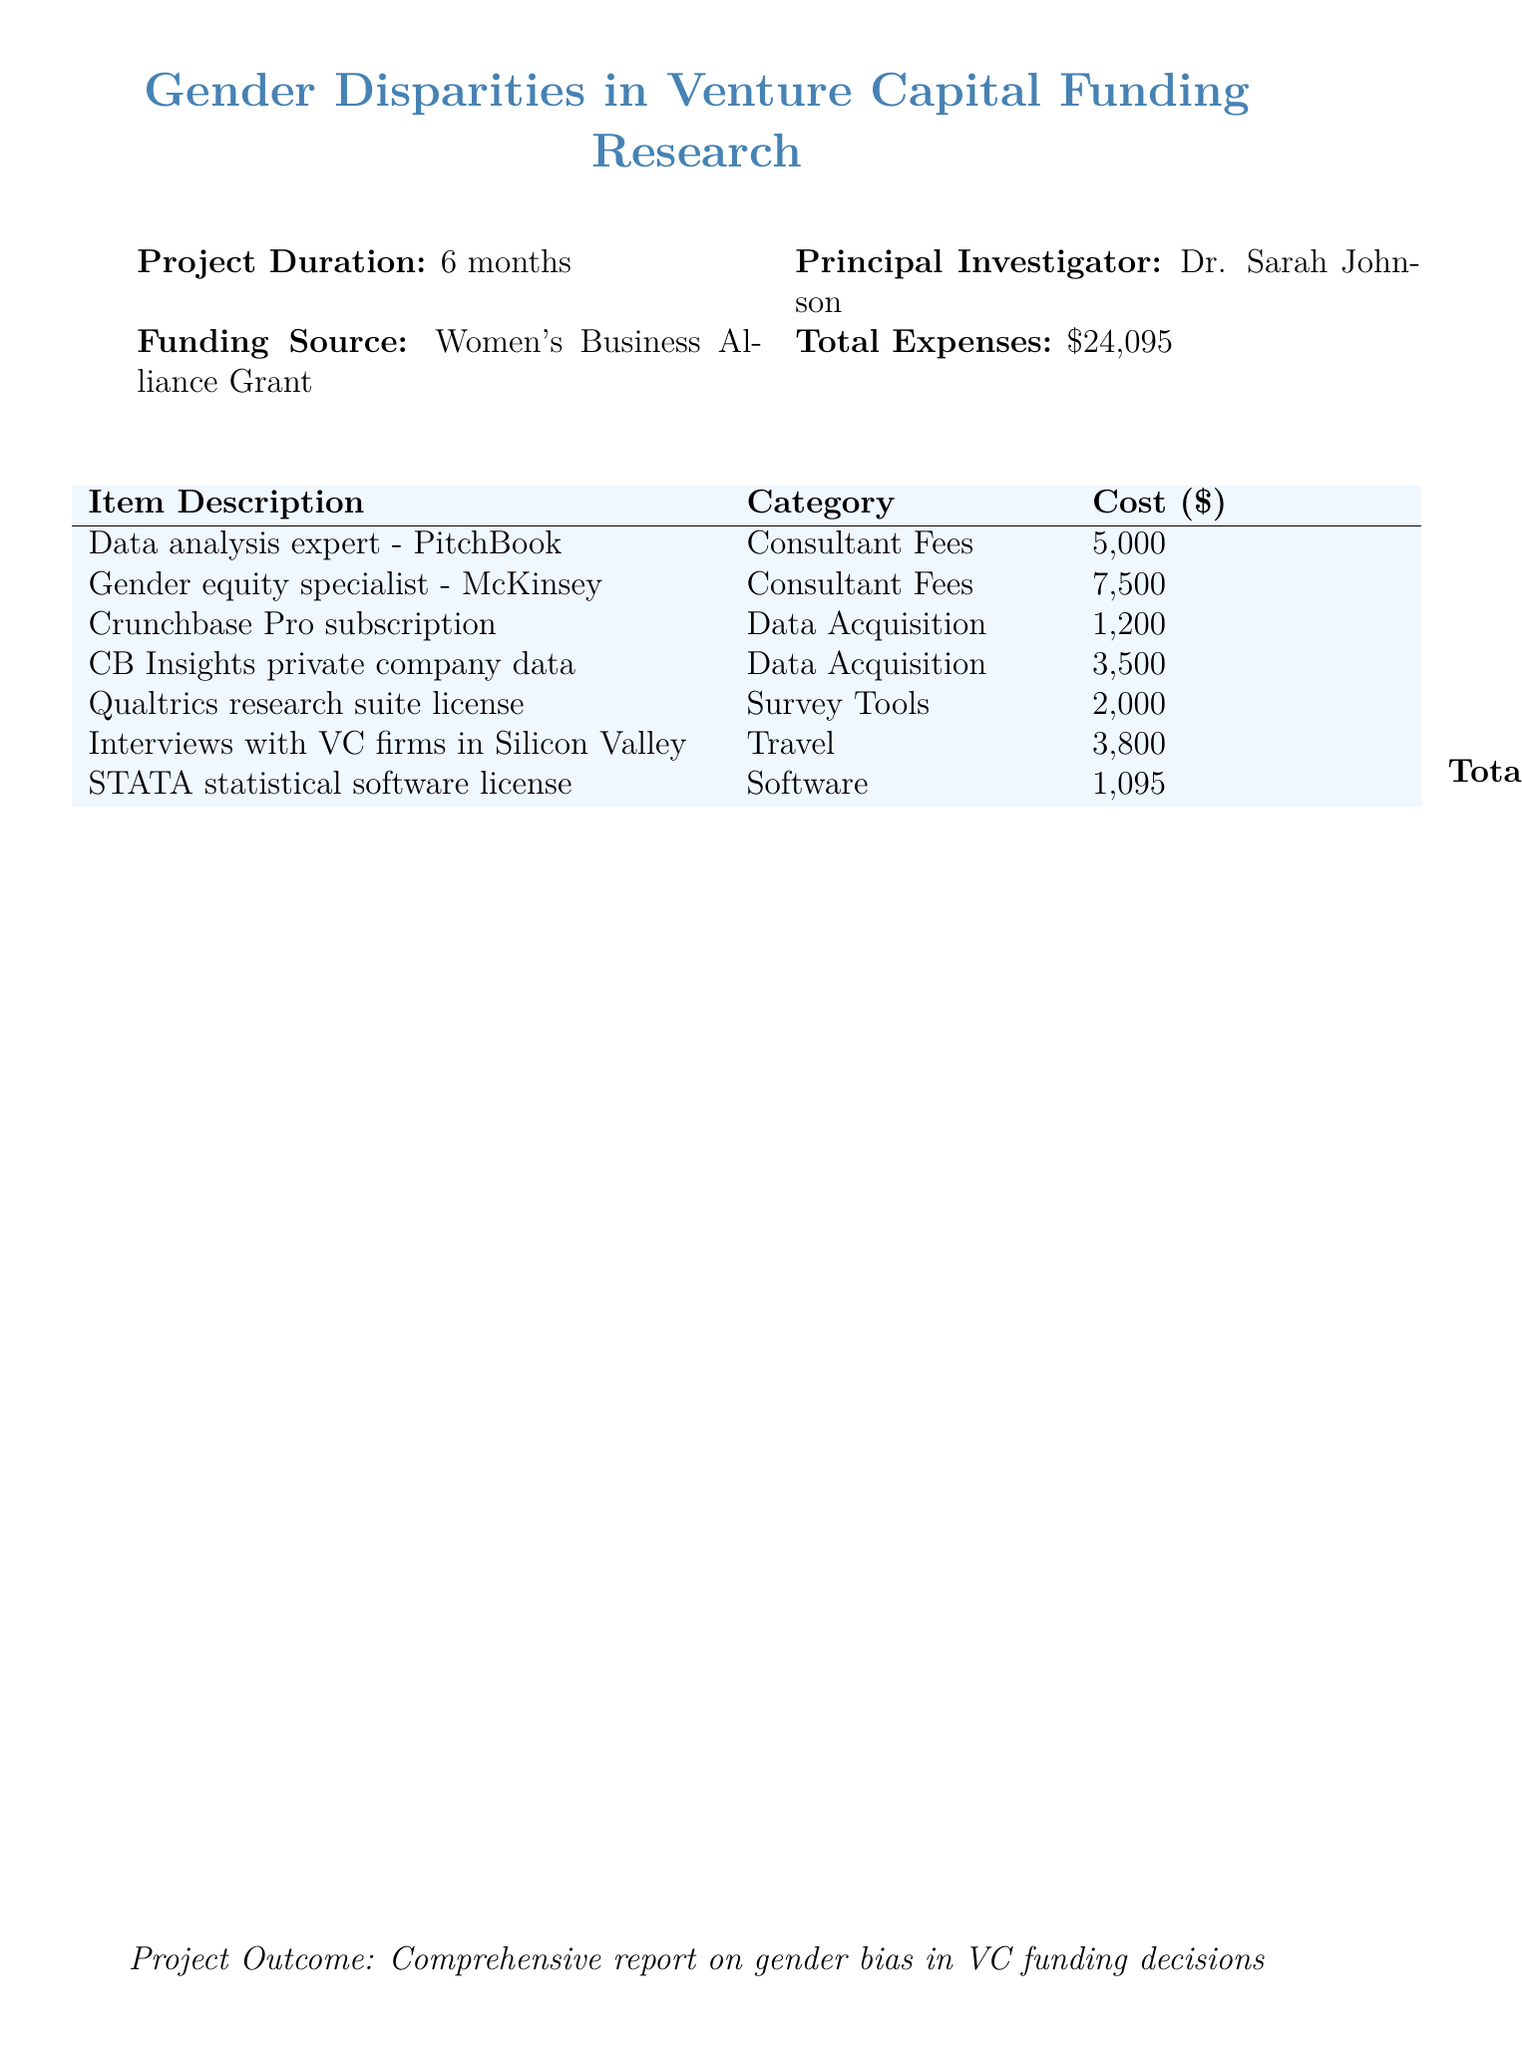What is the total expense for the project? The total expense is listed at the bottom of the document under Total Expenses.
Answer: $24,095 Who is the principal investigator? The principal investigator is provided in the document details concerning the project's leadership.
Answer: Dr. Sarah Johnson What is the funding source for the project? The funding source is mentioned in the document details under Funding Source.
Answer: Women's Business Alliance Grant How much was spent on the Gender equity specialist from McKinsey? This cost is specified in the Consultant Fees section of the expense report.
Answer: $7,500 What tool was used for data acquisition that costs $1,200? The specific tool is named in the Data Acquisition section of the expense report.
Answer: Crunchbase Pro subscription How long is the project duration? The project duration is stated near the top of the document.
Answer: 6 months What category does the STATA software license fall under? The category for STATA is indicated in the expense report table.
Answer: Software What was the purpose of the interviews with VC firms in Silicon Valley? The purpose can be inferred from the context of the research project outlined in the document.
Answer: Travel How much did the data analysis expert from PitchBook cost? This information is detailed in the Consultant Fees section of the expense report.
Answer: $5,000 